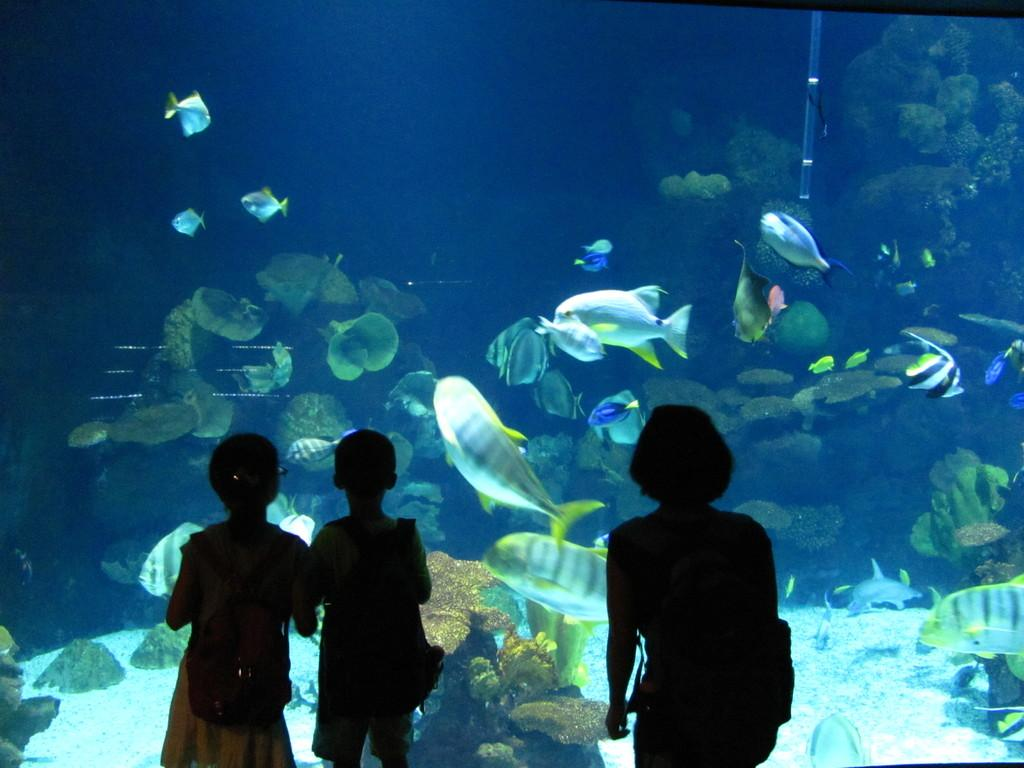How many people are in the image? There are three persons standing in the image. What can be seen in the background of the image? There is an aquarium in the image. What is inside the aquarium? There are fishes, reefs, and rocks in the aquarium. What type of sofa can be seen in the image? There is no sofa present in the image. What shape is the plate on the table in the image? There is no plate present in the image. 